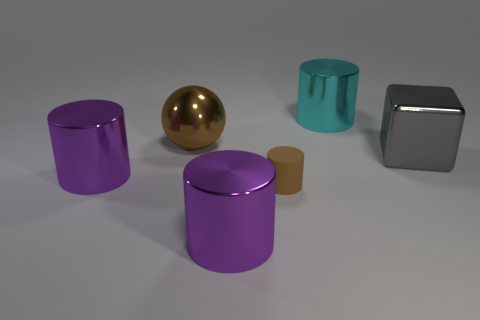Add 1 large gray blocks. How many objects exist? 7 Subtract all big cylinders. How many cylinders are left? 1 Subtract all cylinders. How many objects are left? 2 Subtract 3 cylinders. How many cylinders are left? 1 Subtract all purple blocks. Subtract all cyan balls. How many blocks are left? 1 Subtract all brown spheres. How many green cylinders are left? 0 Subtract all large cylinders. Subtract all large gray shiny things. How many objects are left? 2 Add 1 large metallic cubes. How many large metallic cubes are left? 2 Add 1 small blue rubber objects. How many small blue rubber objects exist? 1 Subtract all cyan cylinders. How many cylinders are left? 3 